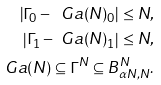Convert formula to latex. <formula><loc_0><loc_0><loc_500><loc_500>\left | \Gamma _ { 0 } - \ G a ( N ) _ { 0 } \right | \leq N , \\ \left | \Gamma _ { 1 } - \ G a ( N ) _ { 1 } \right | \leq N , \\ \ G a ( N ) \subseteq \Gamma ^ { N } \subseteq B _ { \alpha N , N } ^ { N } .</formula> 